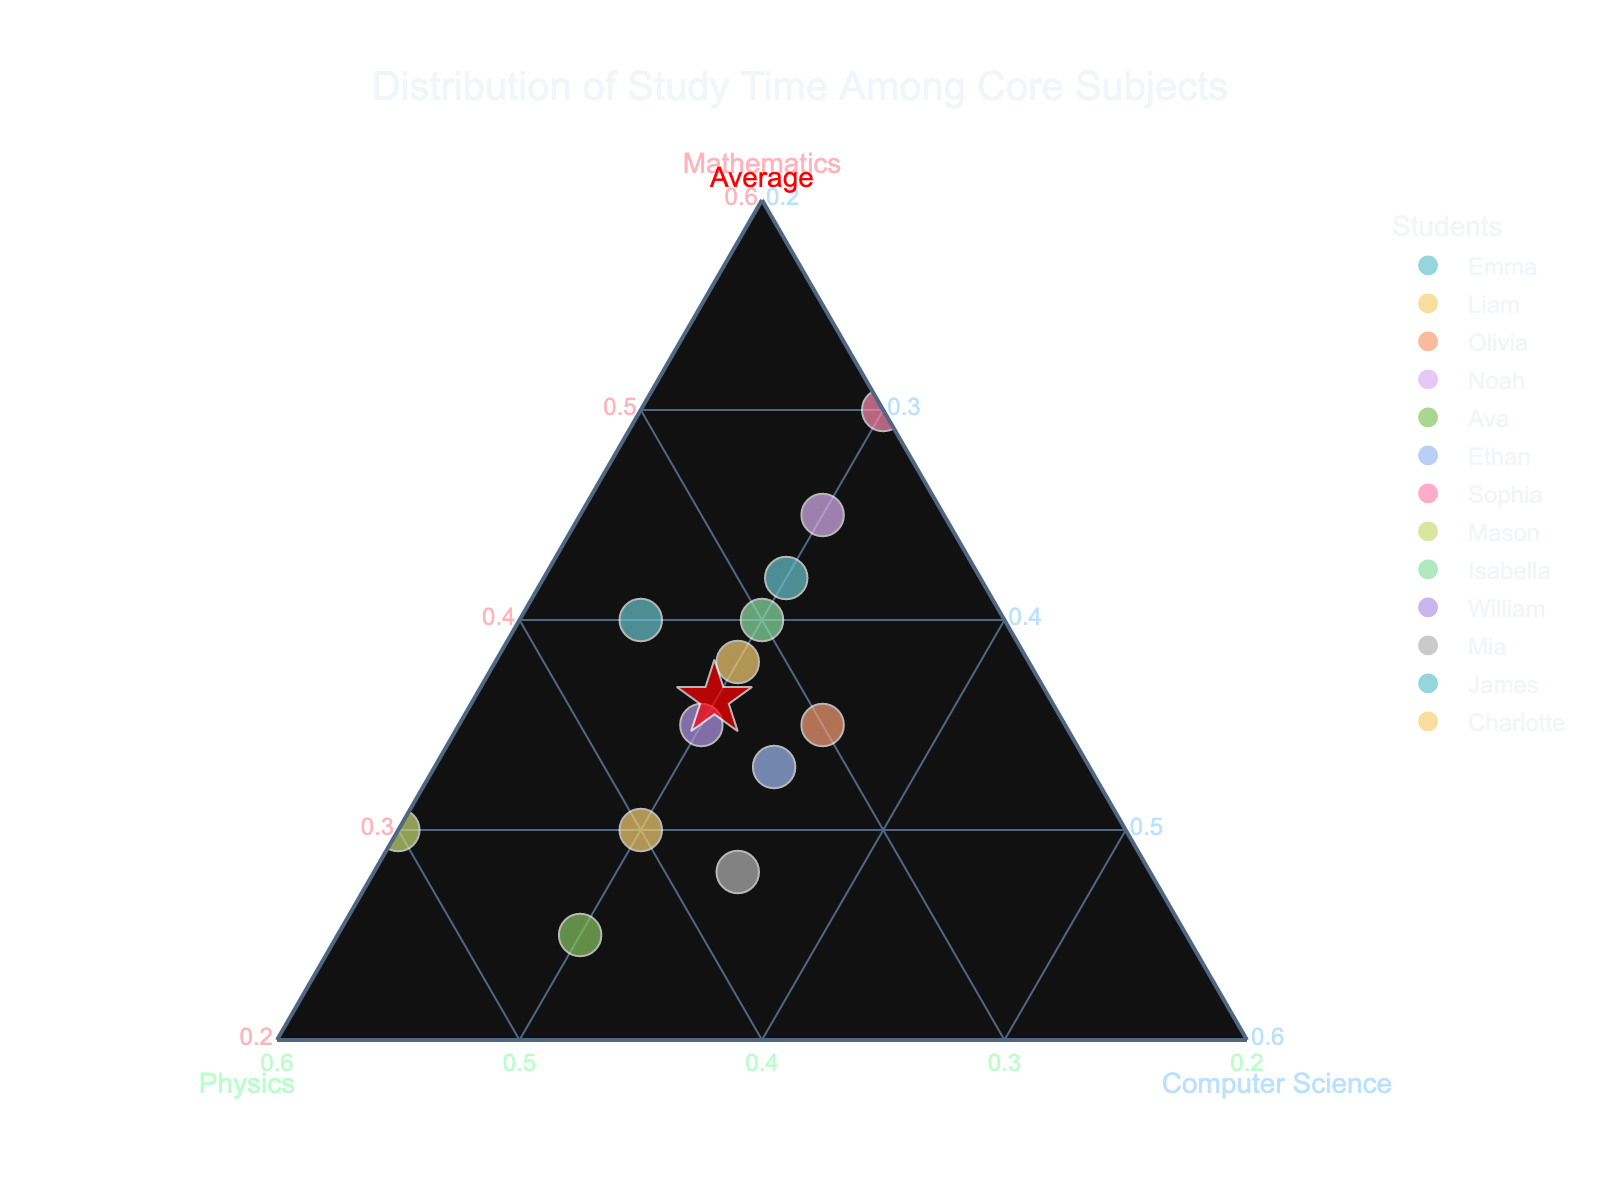What's the title of the plot? The title of the plot is displayed at the top and centered. It is indicative of the main theme or focus of the visualized data.
Answer: Distribution of Study Time Among Core Subjects How many students are represented in the plot? The plot has individual data points for each student. Each colored marker represents one student, and by counting the markers or referring to the legend, one can determine the number of students.
Answer: 14 Which student spends the most time studying Mathematics? By observing the vertices of the triangle corresponding to Mathematics, the student whose data point is closest to this vertex spends the most time in this subject.
Answer: Sophia What is the average study distribution for Mathematics, Physics, and Computer Science? The average is represented by a red star marker labeled "Average." The coordinates of this point can be read off the plot directly.
Answer: Approximately 36.3, 33.4, 30.2 Which subject does Ava spend the most time on? Ava's data point can be identified by looking at its position relative to the vertices of the triangle. The axis where her point is closest indicates her highest dedication.
Answer: Physics Between Liam and Mason, who spends more time on Physics? By locating Liam and Mason's data points and comparing their distances from the Physics vertex, we can determine who spends more time on the subject.
Answer: Mason Is there a student who spends equal time on all three subjects? An equal distribution would place a student’s marker near the center of the ternary plot, equidistant from all three vertices. Olivia’s point appears closest to the center.
Answer: No, but Olivia is closest Who spends the least time on Physics among all students? The point furthest from the Physics vertex (opposite to the Physics corner) indicates the student who spends the least time on Physics.
Answer: Sophia What's the sum of study times for Noah? Noah's study times for each subject need to be summed up using the coordinates of his data point.
Answer: 45 + 25 + 30 = 100 Which students have a similar study distribution? Students with data points that are close to each other on the ternary plot have similar study distributions. By visually inspecting the plot, we can identify the clusters.
Answer: Isabella and Emma 